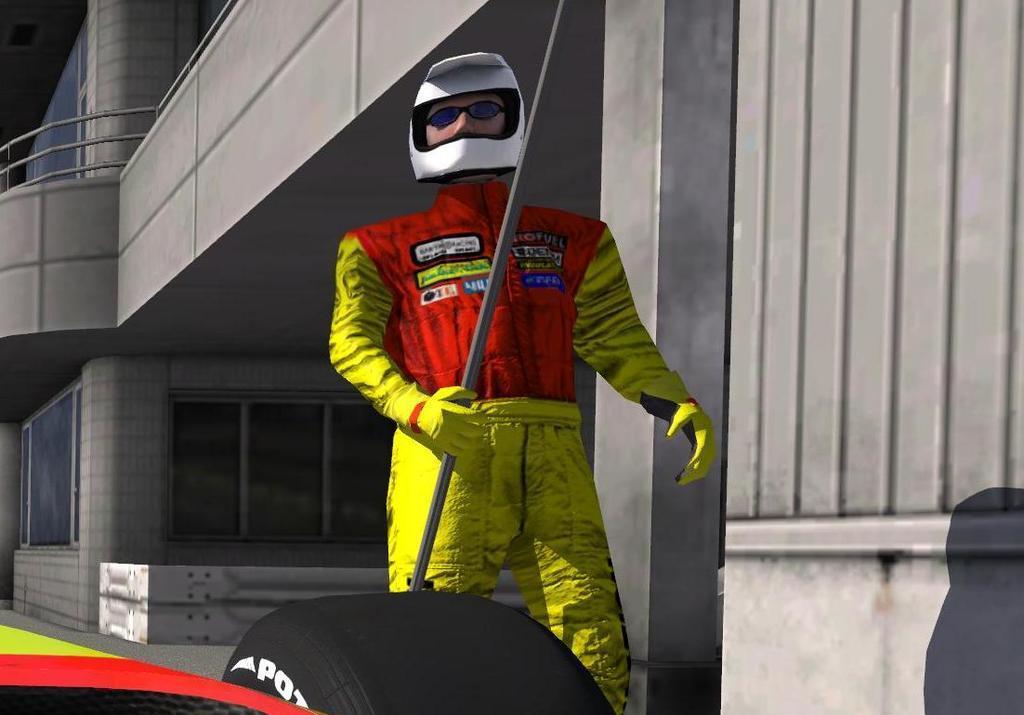Please provide a concise description of this image. This is an animation and here we can see a person wearing a helmet and holding a stick. In the background, there is a building and we can see railings. At the bottom, there is a vehicle on the road. 